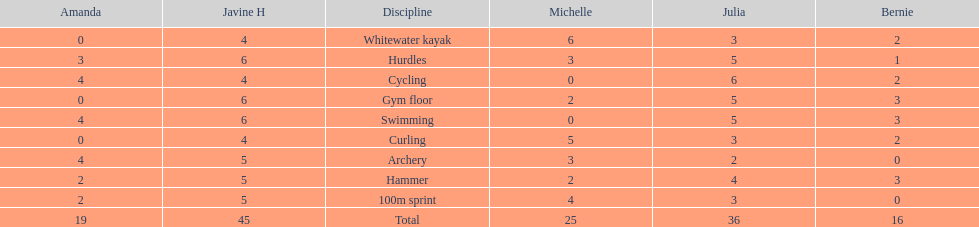What is the last discipline listed on this chart? 100m sprint. 